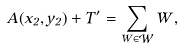<formula> <loc_0><loc_0><loc_500><loc_500>A ( x _ { 2 } , y _ { 2 } ) + T ^ { \prime } = \sum _ { W \in { \mathcal { W } } } W ,</formula> 